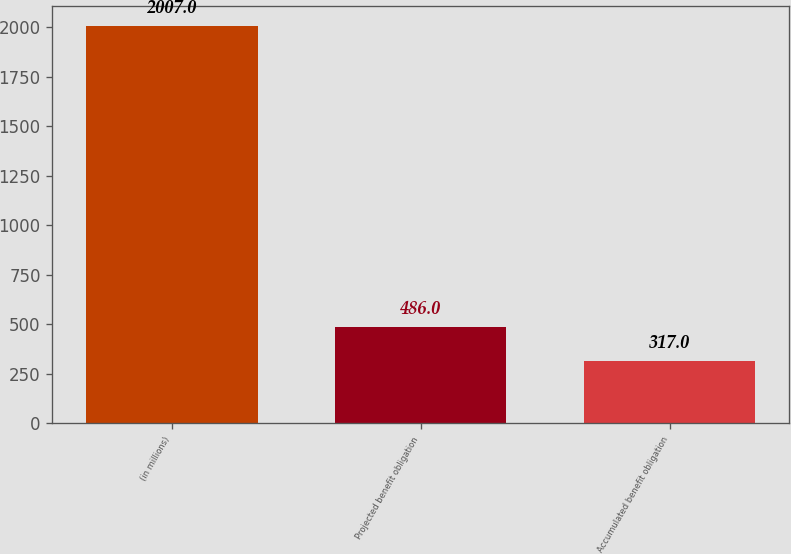Convert chart to OTSL. <chart><loc_0><loc_0><loc_500><loc_500><bar_chart><fcel>(in millions)<fcel>Projected benefit obligation<fcel>Accumulated benefit obligation<nl><fcel>2007<fcel>486<fcel>317<nl></chart> 